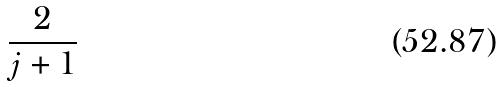Convert formula to latex. <formula><loc_0><loc_0><loc_500><loc_500>\frac { 2 } { j + 1 }</formula> 